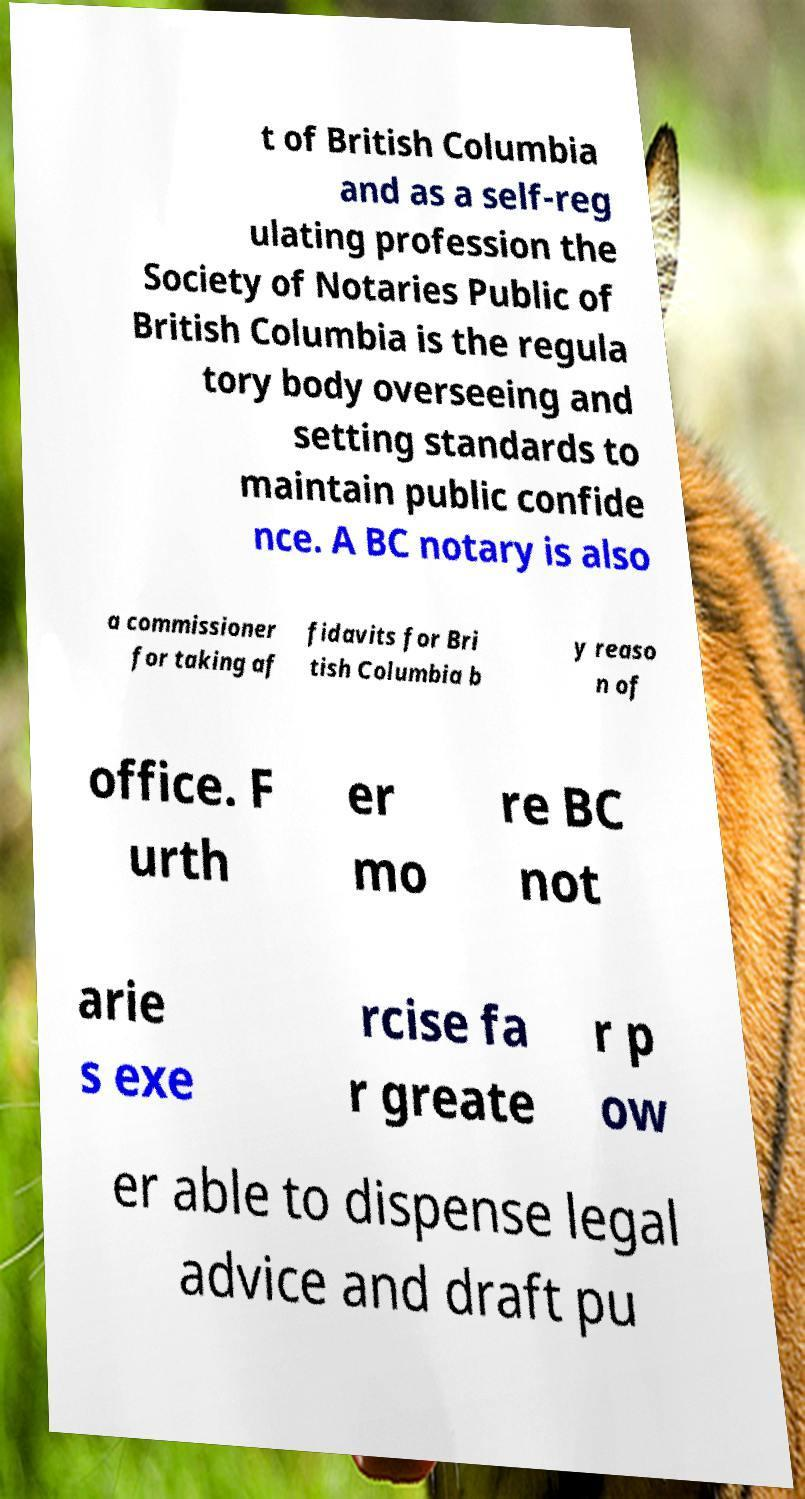Please identify and transcribe the text found in this image. t of British Columbia and as a self-reg ulating profession the Society of Notaries Public of British Columbia is the regula tory body overseeing and setting standards to maintain public confide nce. A BC notary is also a commissioner for taking af fidavits for Bri tish Columbia b y reaso n of office. F urth er mo re BC not arie s exe rcise fa r greate r p ow er able to dispense legal advice and draft pu 